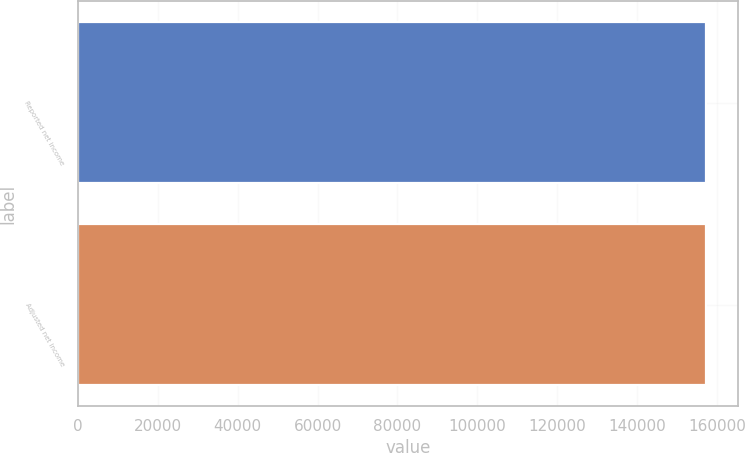Convert chart to OTSL. <chart><loc_0><loc_0><loc_500><loc_500><bar_chart><fcel>Reported net income<fcel>Adjusted net income<nl><fcel>157329<fcel>157329<nl></chart> 